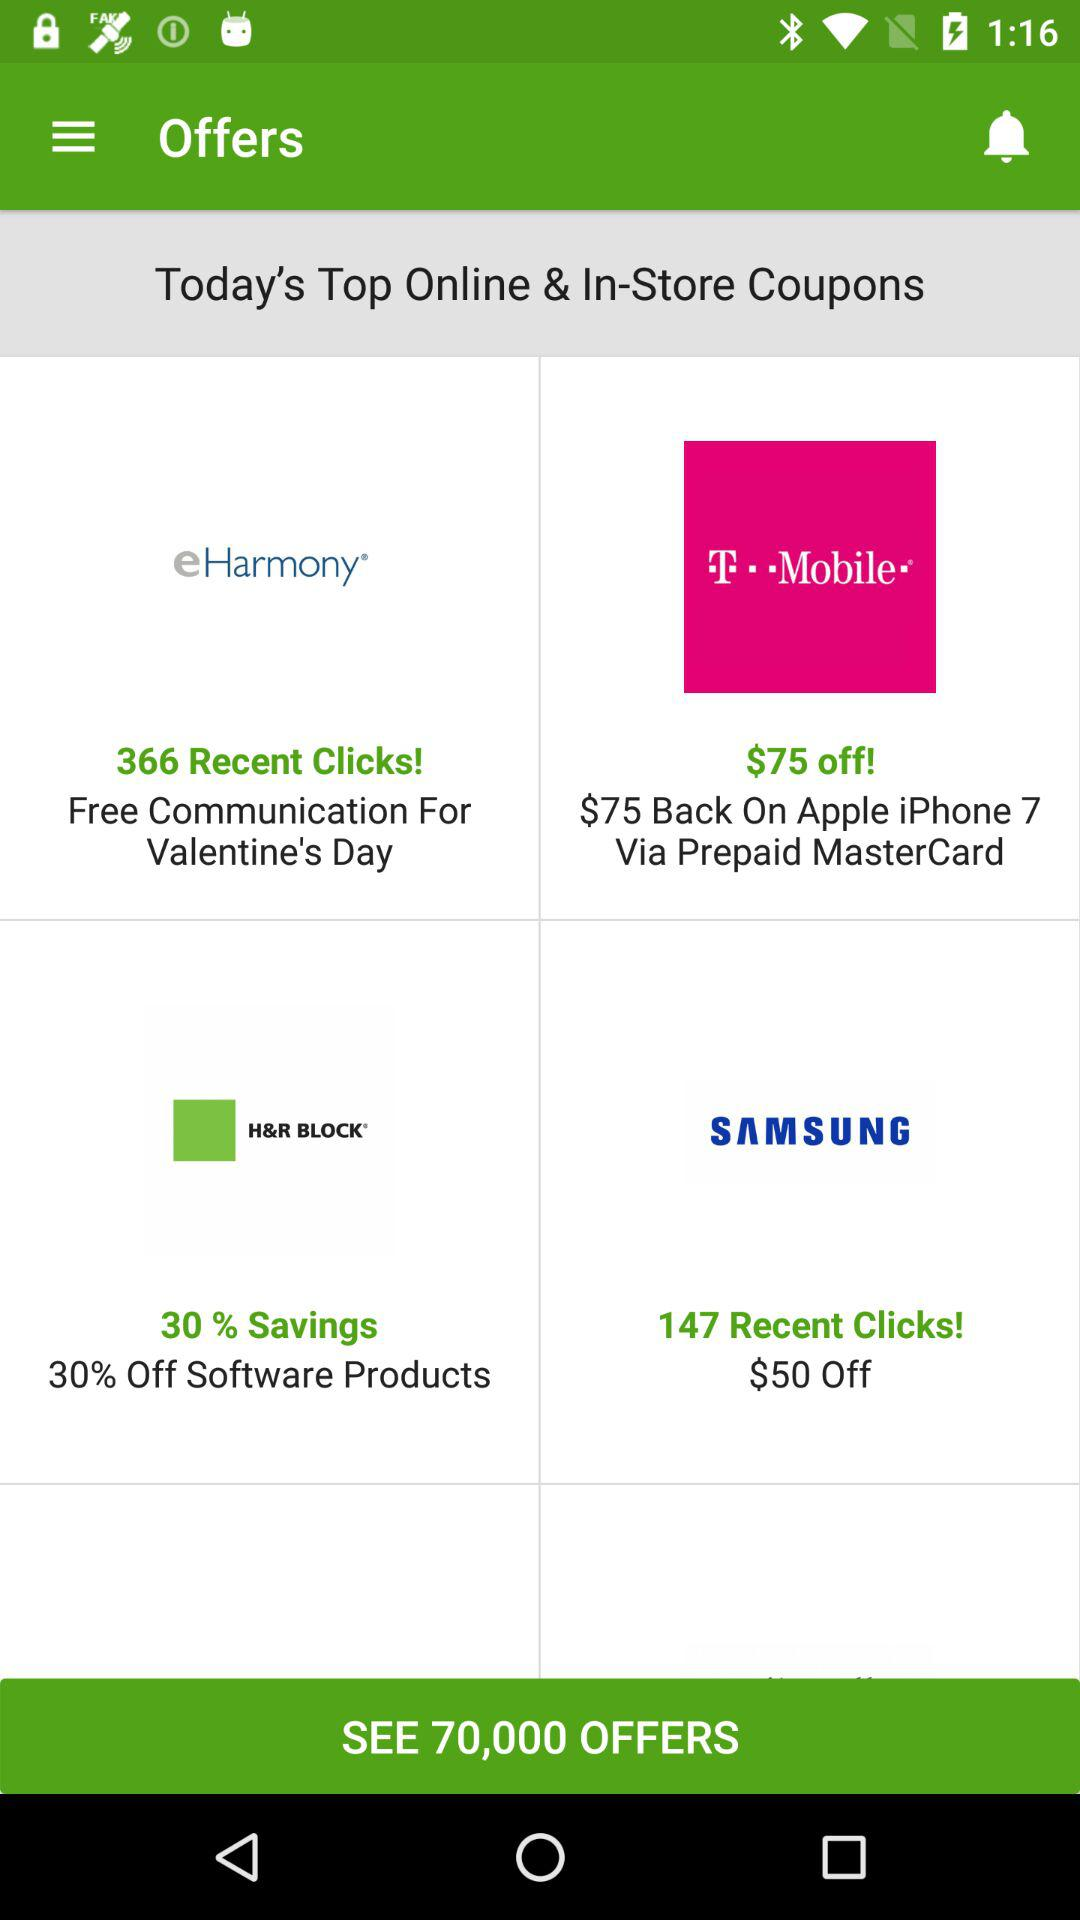How much is the discount on Samsung? There is a $50 discount. 